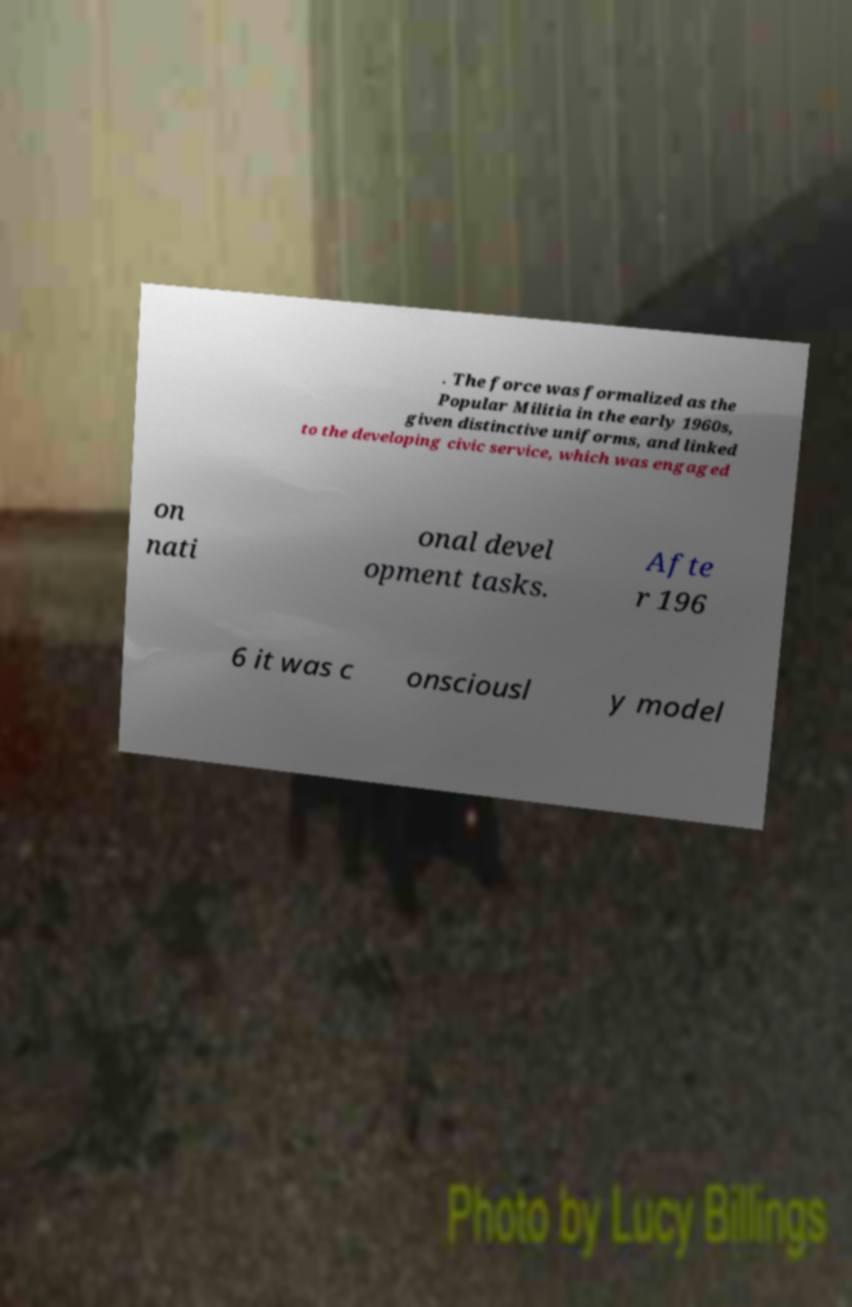Please identify and transcribe the text found in this image. . The force was formalized as the Popular Militia in the early 1960s, given distinctive uniforms, and linked to the developing civic service, which was engaged on nati onal devel opment tasks. Afte r 196 6 it was c onsciousl y model 